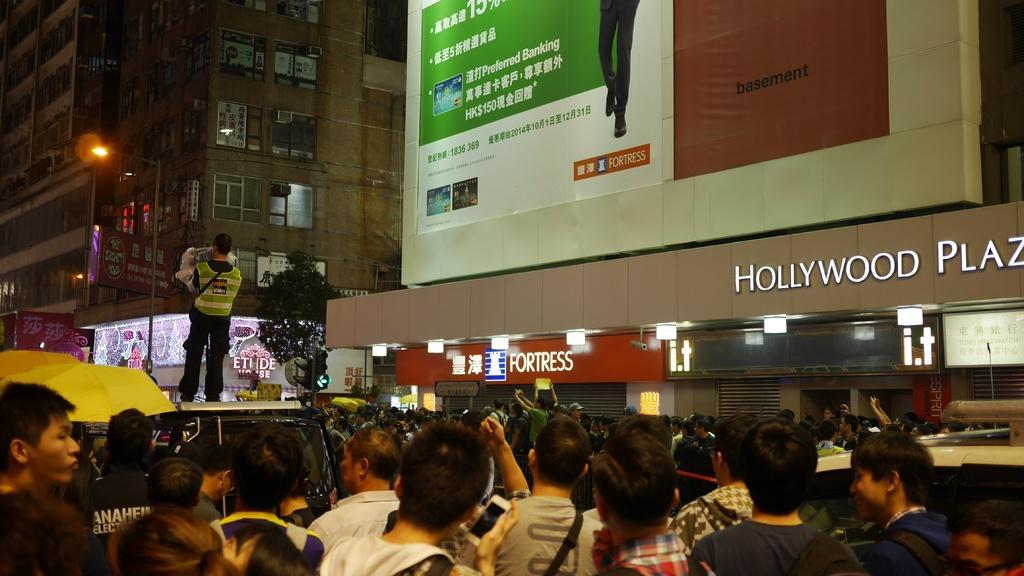Please provide a concise description of this image. In this picture I can see there is a man standing on a surface and there are few umbrellas, banners on the buildings, there is a huge crowd of people and there are few trees and lights. 